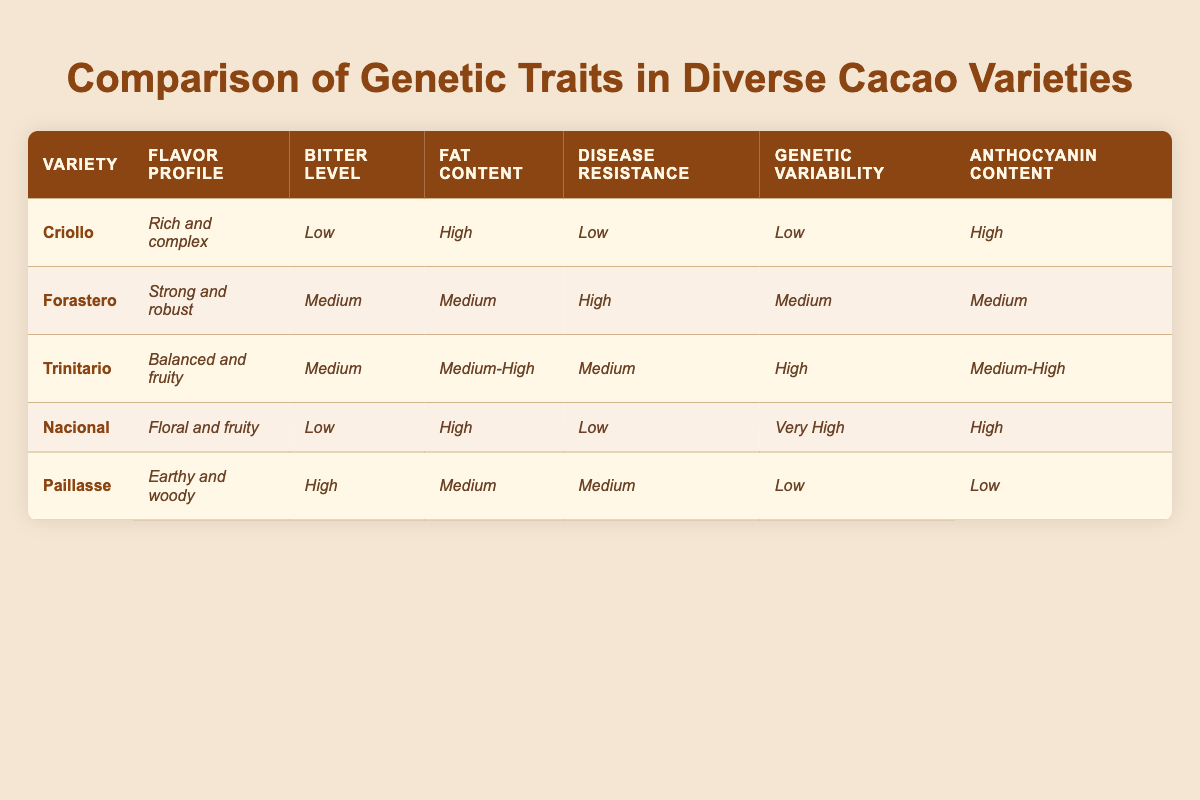What is the flavor profile of the Criollo variety? The table shows that the Criollo variety has a flavor profile described as "Rich and complex."
Answer: Rich and complex Which variety has the highest fat content? By comparing the fat content values, both Criollo and Nacional have a high fat content, but Nacional has a slightly higher value categorized as "High," while Criollo is listed as "High," indicating they are tied.
Answer: Criollo and Nacional Does the Forastero variety have high disease resistance? The table indicates that Forastero has a disease resistance level classified as "High."
Answer: Yes Which cacao variety has the lowest level of genetic variability? The Criollo and Paillasse varieties both exhibit low genetic variability, but Criollo is listed as "Low" while Paillasse is also listed "Low."
Answer: Criollo and Paillasse What is the average bitter level of the Trinitario and Forastero varieties? Both Trinitario and Forastero have a medium bitter level. The average level can be calculated as (Medium + Medium)/2 = Medium
Answer: Medium Which cacao variety has the highest anthocyanin content? Upon examining the table, the Nacional variety shows a high level of anthocyanin content classified as "High," which is higher than the other varieties listed.
Answer: Nacional Is there a variety with both low disease resistance and genetic variability? The Criollo variety has both low disease resistance and low genetic variability according to the table.
Answer: Yes Calculate the total number of varieties with high anthocyanin content. The varieties with high anthocyanin content are Criollo, Nacional, and Trinitario; thus, there are a total of 3 varieties with high anthocyanin content.
Answer: 3 How does the flavor profile of the Nacional variety compare to that of the Paillasse variety? The Nacional variety has a "Floral and fruity" flavor profile, while the Paillasse variety is described as having an "Earthy and woody" profile, indicating a significant difference in flavor characteristics.
Answer: Different Which variety has a lower fat content: Forastero or Trinitario? The Forastero variety has a "Medium" fat content, while Trinitario is classified as "Medium-High," indicating that Forastero has a lower fat content.
Answer: Forastero 